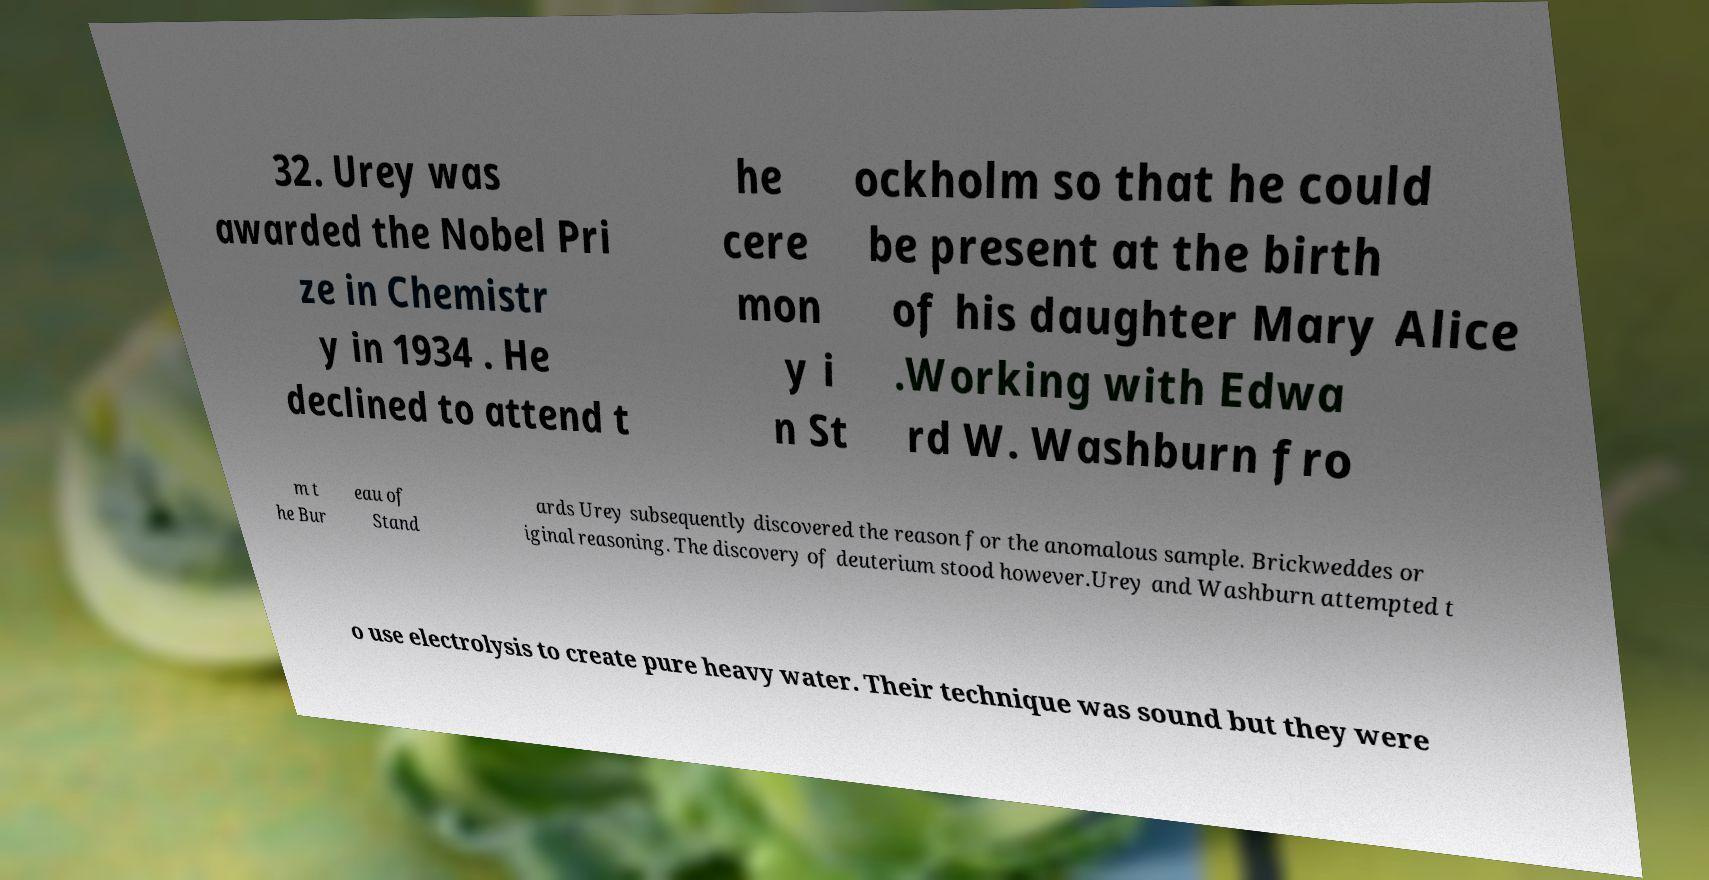Could you assist in decoding the text presented in this image and type it out clearly? 32. Urey was awarded the Nobel Pri ze in Chemistr y in 1934 . He declined to attend t he cere mon y i n St ockholm so that he could be present at the birth of his daughter Mary Alice .Working with Edwa rd W. Washburn fro m t he Bur eau of Stand ards Urey subsequently discovered the reason for the anomalous sample. Brickweddes or iginal reasoning. The discovery of deuterium stood however.Urey and Washburn attempted t o use electrolysis to create pure heavy water. Their technique was sound but they were 